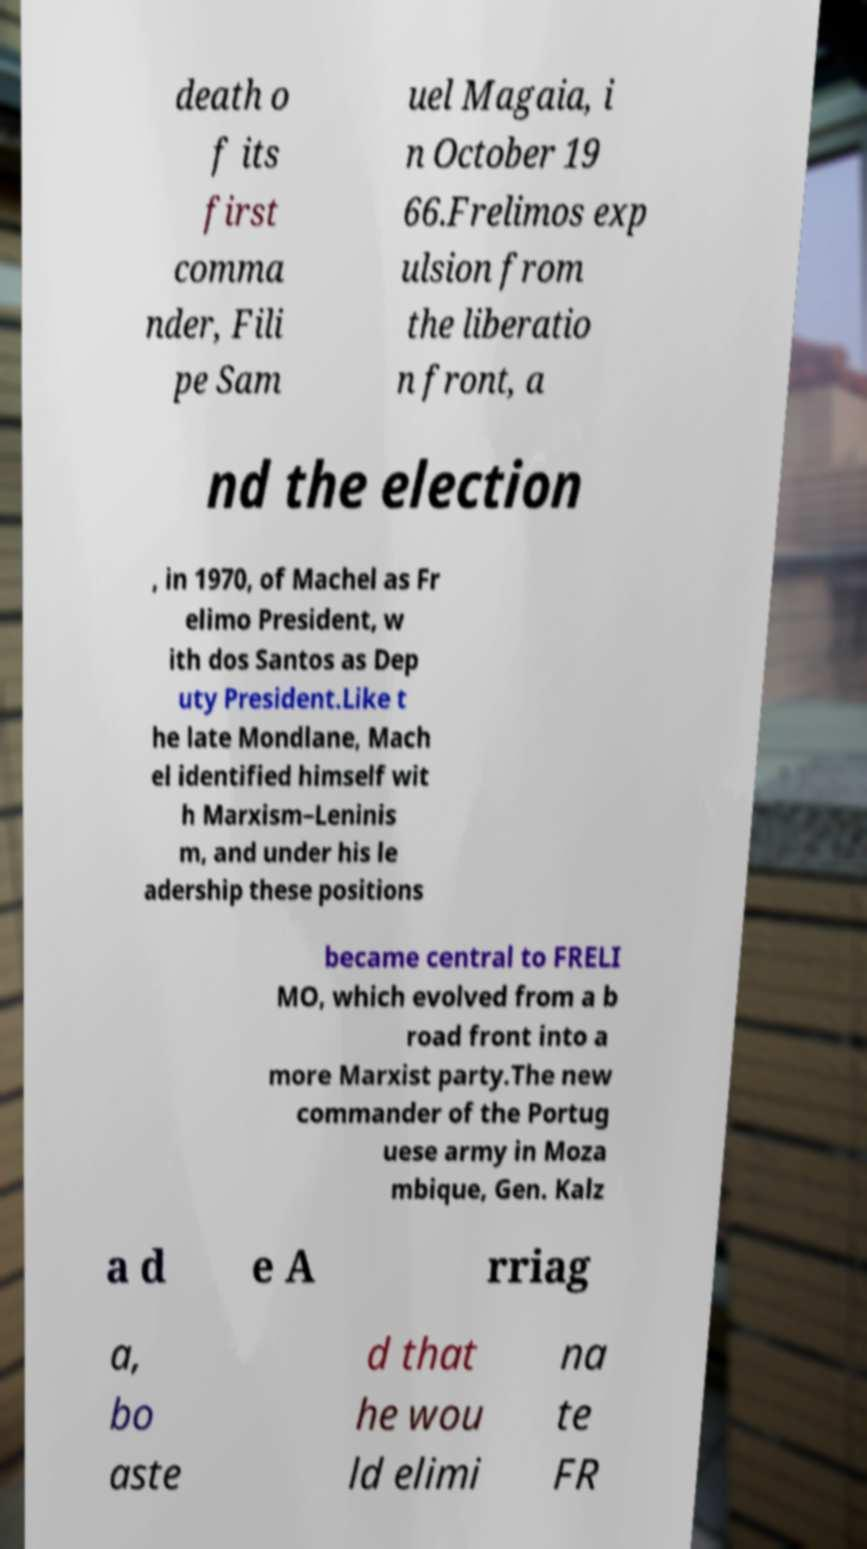Can you accurately transcribe the text from the provided image for me? death o f its first comma nder, Fili pe Sam uel Magaia, i n October 19 66.Frelimos exp ulsion from the liberatio n front, a nd the election , in 1970, of Machel as Fr elimo President, w ith dos Santos as Dep uty President.Like t he late Mondlane, Mach el identified himself wit h Marxism–Leninis m, and under his le adership these positions became central to FRELI MO, which evolved from a b road front into a more Marxist party.The new commander of the Portug uese army in Moza mbique, Gen. Kalz a d e A rriag a, bo aste d that he wou ld elimi na te FR 